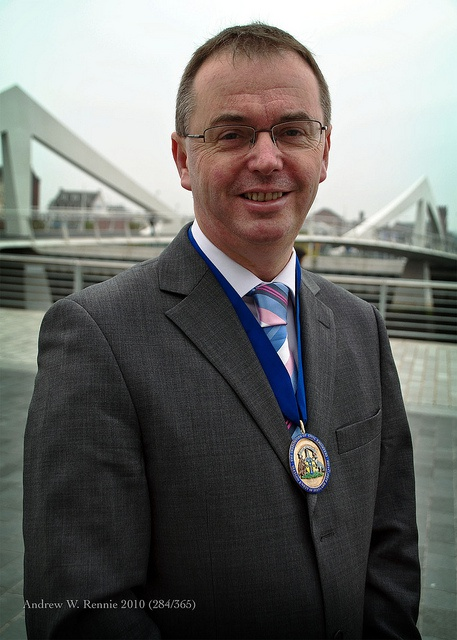Describe the objects in this image and their specific colors. I can see people in lightblue, black, gray, and maroon tones and tie in lightblue, gray, lavender, and navy tones in this image. 